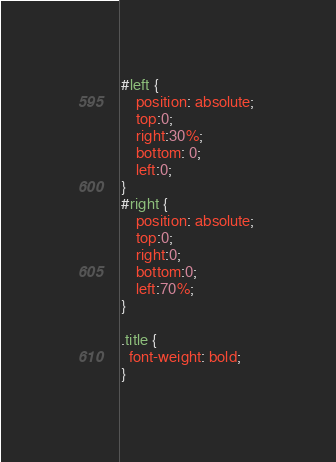Convert code to text. <code><loc_0><loc_0><loc_500><loc_500><_CSS_>#left { 
	position: absolute; 
	top:0;
	right:30%;
	bottom: 0;
	left:0;  
}
#right { 
	position: absolute; 
	top:0;
	right:0; 
	bottom:0; 
	left:70%; 
}

.title {
  font-weight: bold;
}</code> 